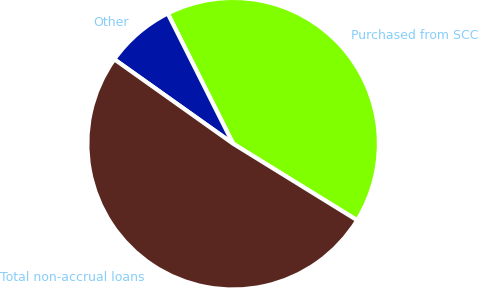Convert chart. <chart><loc_0><loc_0><loc_500><loc_500><pie_chart><fcel>Purchased from SCC<fcel>Other<fcel>Total non-accrual loans<nl><fcel>41.21%<fcel>7.76%<fcel>51.03%<nl></chart> 